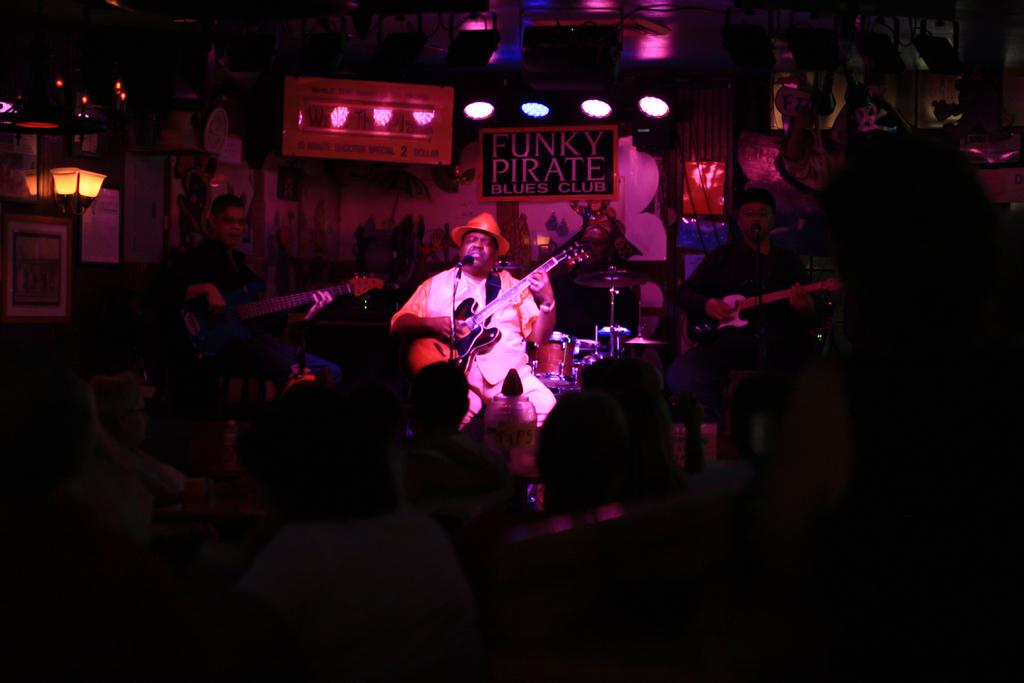What are the people in the image doing while standing on chairs? They are playing the guitar. What other musical instruments can be seen in the image? There are other musical instruments in the image. What can be observed in the image that provides illumination? There are lights visible in the image. How would you describe the overall lighting in the image? The background of the image is dark. What type of lead is being used by the guitarist in the image? There is no mention of a specific type of lead in the image, as the focus is on the people playing the guitar while standing on chairs. 